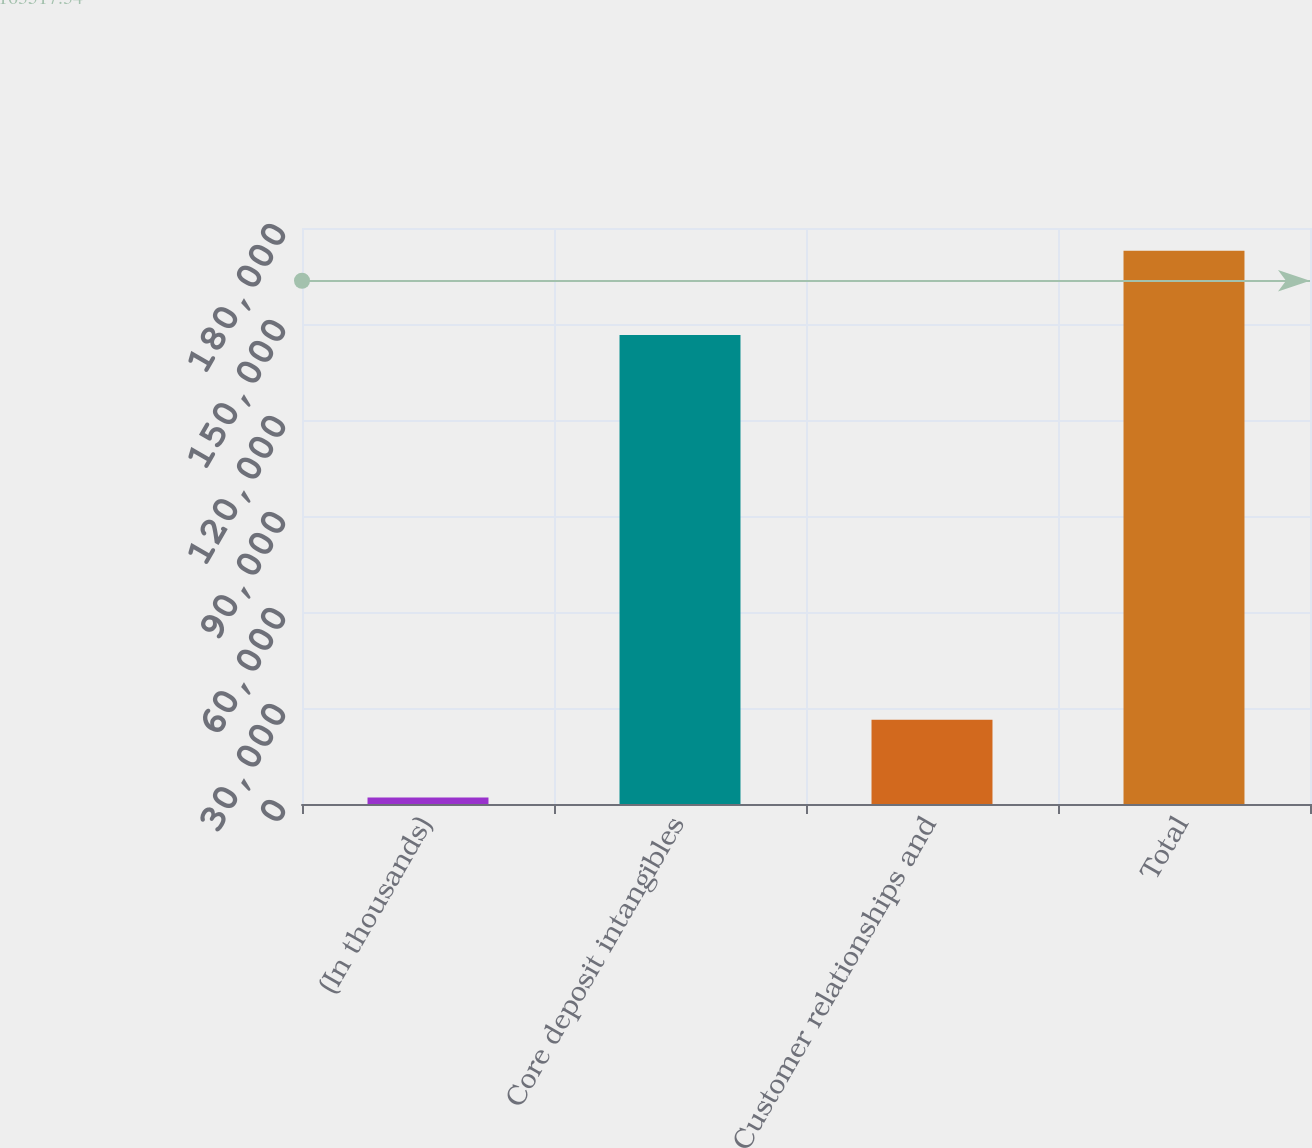<chart> <loc_0><loc_0><loc_500><loc_500><bar_chart><fcel>(In thousands)<fcel>Core deposit intangibles<fcel>Customer relationships and<fcel>Total<nl><fcel>2013<fcel>146557<fcel>26353<fcel>172910<nl></chart> 